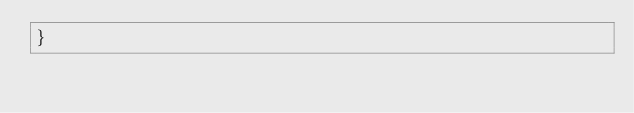Convert code to text. <code><loc_0><loc_0><loc_500><loc_500><_TypeScript_>}
</code> 